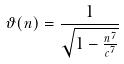Convert formula to latex. <formula><loc_0><loc_0><loc_500><loc_500>\vartheta ( n ) = \frac { 1 } { \sqrt { 1 - \frac { n ^ { 7 } } { c ^ { 7 } } } }</formula> 